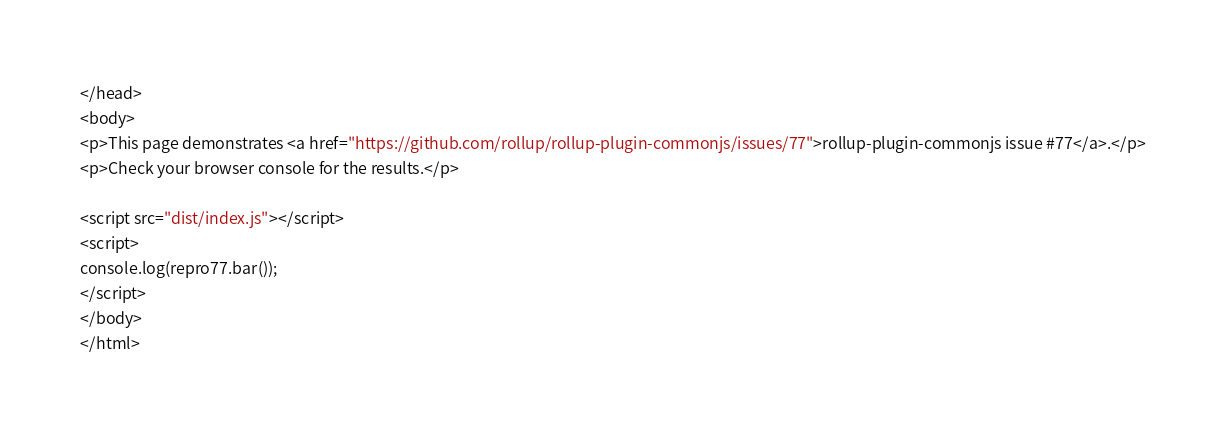<code> <loc_0><loc_0><loc_500><loc_500><_HTML_></head>
<body>
<p>This page demonstrates <a href="https://github.com/rollup/rollup-plugin-commonjs/issues/77">rollup-plugin-commonjs issue #77</a>.</p>
<p>Check your browser console for the results.</p>

<script src="dist/index.js"></script>
<script>
console.log(repro77.bar());
</script>
</body>
</html></code> 